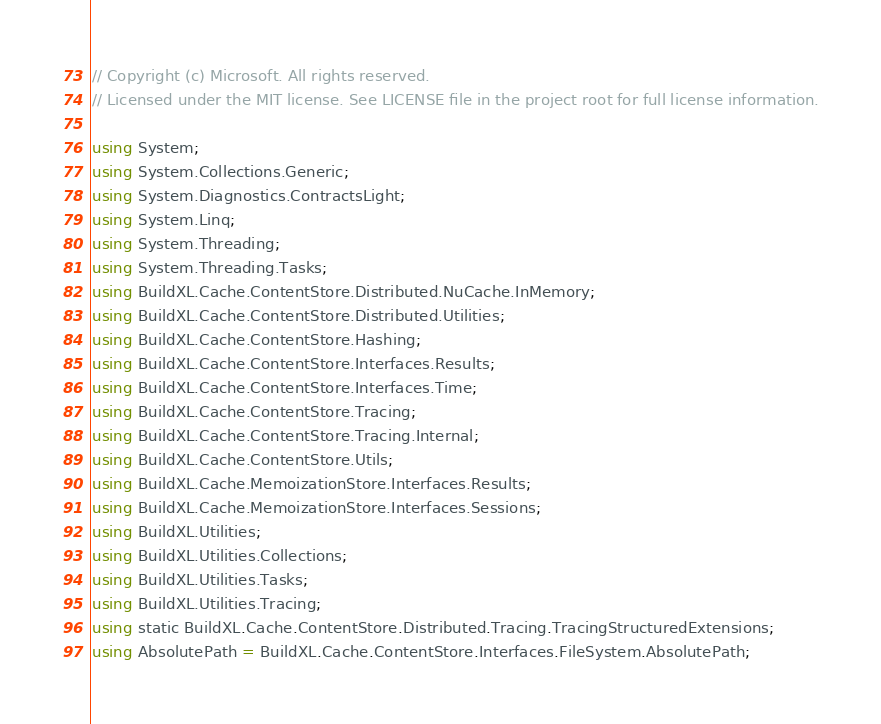<code> <loc_0><loc_0><loc_500><loc_500><_C#_>// Copyright (c) Microsoft. All rights reserved.
// Licensed under the MIT license. See LICENSE file in the project root for full license information.

using System;
using System.Collections.Generic;
using System.Diagnostics.ContractsLight;
using System.Linq;
using System.Threading;
using System.Threading.Tasks;
using BuildXL.Cache.ContentStore.Distributed.NuCache.InMemory;
using BuildXL.Cache.ContentStore.Distributed.Utilities;
using BuildXL.Cache.ContentStore.Hashing;
using BuildXL.Cache.ContentStore.Interfaces.Results;
using BuildXL.Cache.ContentStore.Interfaces.Time;
using BuildXL.Cache.ContentStore.Tracing;
using BuildXL.Cache.ContentStore.Tracing.Internal;
using BuildXL.Cache.ContentStore.Utils;
using BuildXL.Cache.MemoizationStore.Interfaces.Results;
using BuildXL.Cache.MemoizationStore.Interfaces.Sessions;
using BuildXL.Utilities;
using BuildXL.Utilities.Collections;
using BuildXL.Utilities.Tasks;
using BuildXL.Utilities.Tracing;
using static BuildXL.Cache.ContentStore.Distributed.Tracing.TracingStructuredExtensions;
using AbsolutePath = BuildXL.Cache.ContentStore.Interfaces.FileSystem.AbsolutePath;
</code> 